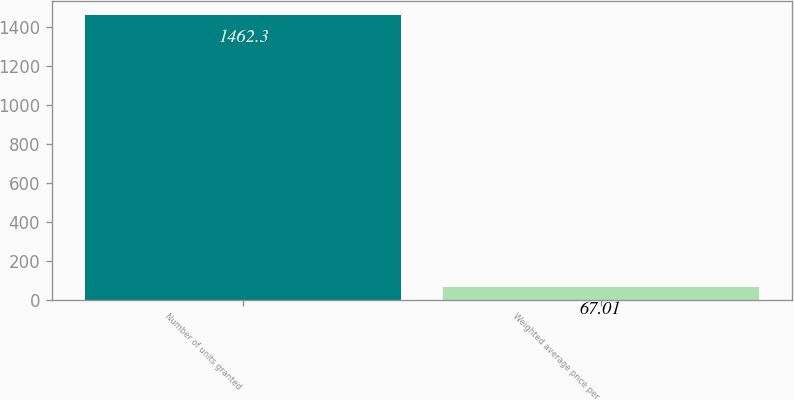Convert chart to OTSL. <chart><loc_0><loc_0><loc_500><loc_500><bar_chart><fcel>Number of units granted<fcel>Weighted average price per<nl><fcel>1462.3<fcel>67.01<nl></chart> 